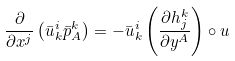Convert formula to latex. <formula><loc_0><loc_0><loc_500><loc_500>\frac { \partial } { \partial x ^ { j } } \left ( \bar { u } ^ { i } _ { k } \bar { p } ^ { k } _ { A } \right ) = - \bar { u } ^ { i } _ { k } \left ( \frac { \partial h ^ { k } _ { j } } { \partial y ^ { A } } \right ) \circ u</formula> 